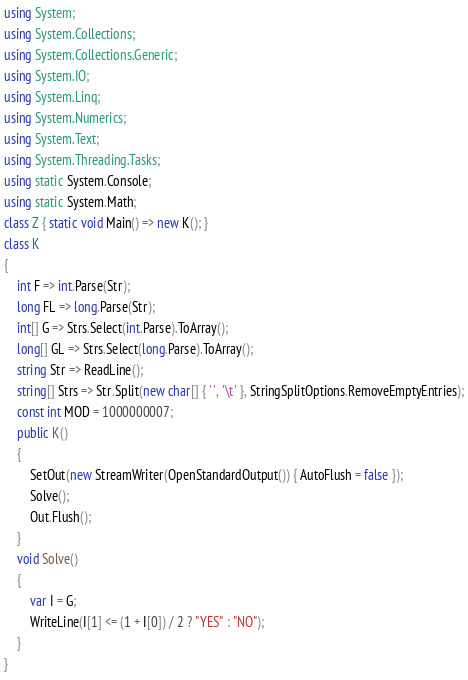<code> <loc_0><loc_0><loc_500><loc_500><_C#_>using System;
using System.Collections;
using System.Collections.Generic;
using System.IO;
using System.Linq;
using System.Numerics;
using System.Text;
using System.Threading.Tasks;
using static System.Console;
using static System.Math;
class Z { static void Main() => new K(); }
class K
{
    int F => int.Parse(Str);
    long FL => long.Parse(Str);
    int[] G => Strs.Select(int.Parse).ToArray();
    long[] GL => Strs.Select(long.Parse).ToArray();
    string Str => ReadLine();
    string[] Strs => Str.Split(new char[] { ' ', '\t' }, StringSplitOptions.RemoveEmptyEntries);
    const int MOD = 1000000007;
    public K()
    {
        SetOut(new StreamWriter(OpenStandardOutput()) { AutoFlush = false });
        Solve();
        Out.Flush();
    }
    void Solve()
    {
        var I = G;
        WriteLine(I[1] <= (1 + I[0]) / 2 ? "YES" : "NO");
    }
}
</code> 